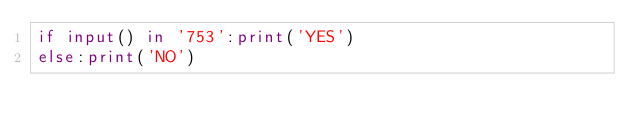<code> <loc_0><loc_0><loc_500><loc_500><_Python_>if input() in '753':print('YES')
else:print('NO')</code> 